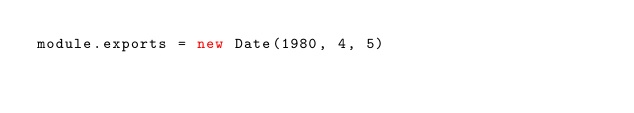<code> <loc_0><loc_0><loc_500><loc_500><_JavaScript_>module.exports = new Date(1980, 4, 5)
</code> 